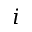<formula> <loc_0><loc_0><loc_500><loc_500>i</formula> 